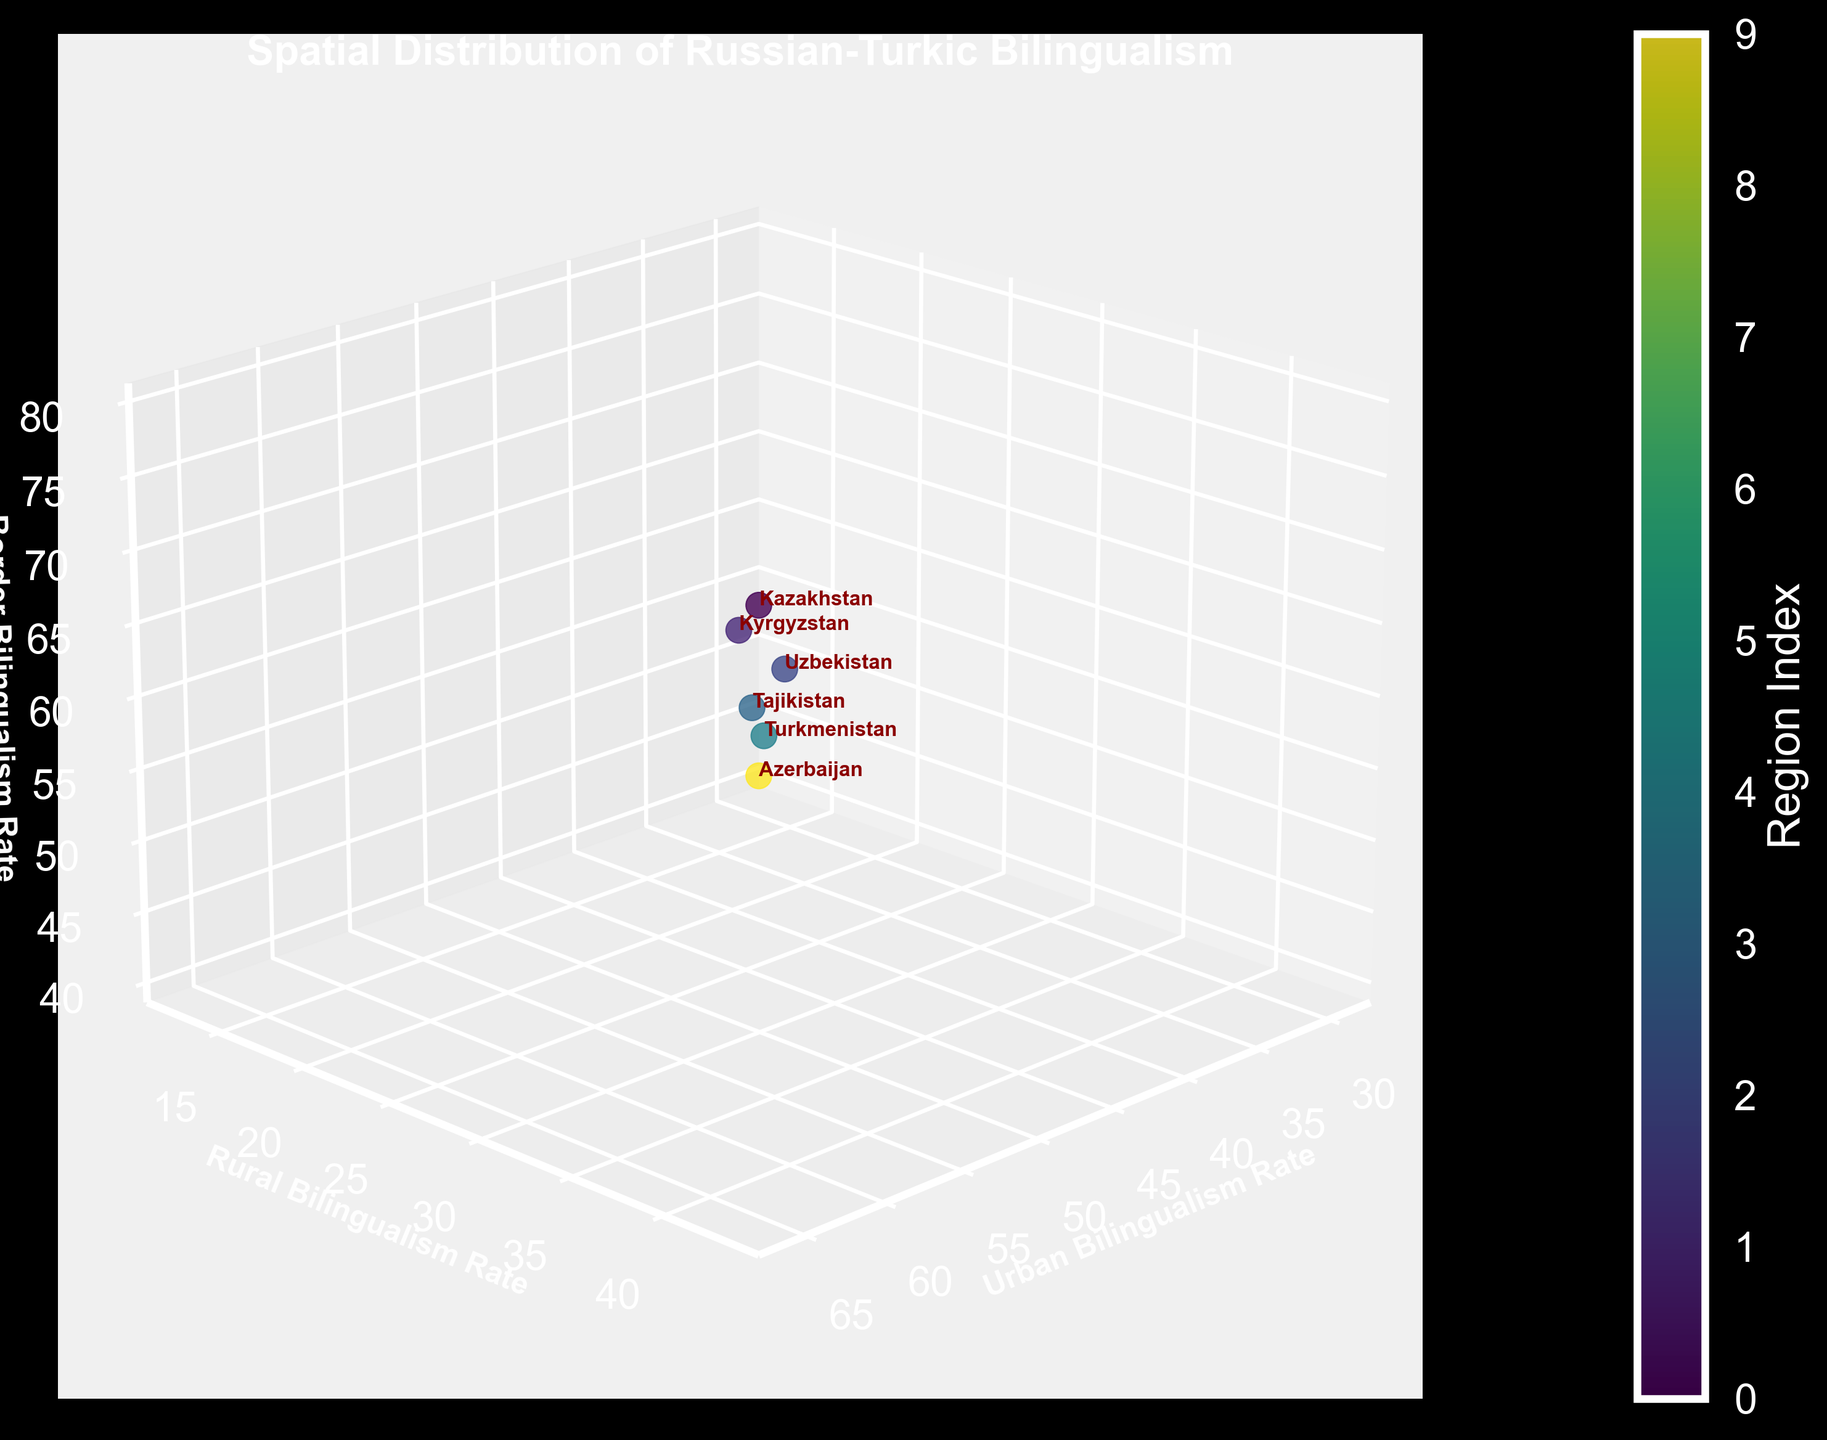What's the title of the figure? The title is typically the most prominent text in a figure, usually located at the top. In this case, the title is clearly stated at the top of the 3D plot: "Spatial Distribution of Russian-Turkic Bilingualism".
Answer: Spatial Distribution of Russian-Turkic Bilingualism Which region has the highest urban bilingualism rate? The figure displays the urban bilingualism rates along the x-axis. By looking for the region highest on this axis, we can identify Tatarstan with an urban bilingualism rate of 76.2.
Answer: Tatarstan Which regions do not have data for border bilingualism rates? By examining the z-axis values and the regions labeled, we can see that Tatarstan, Bashkortostan, Chuvashia, and Yakutia lack data points on the border bilingualism axis.
Answer: Tatarstan, Bashkortostan, Chuvashia, Yakutia What's the rural bilingualism rate of Kyrgyzstan? The y-axis represents the rural bilingualism rates. By locating Kyrgyzstan's label near this axis, we see it is positioned at a rural bilingualism rate of 36.2.
Answer: 36.2 Which region has the lowest border bilingualism rate, and what is it? The z-axis shows the border bilingualism rates. By identifying the lowest point on this axis, Azerbaijan has the lowest rate at 41.3.
Answer: Azerbaijan, 41.3 Compare the urban and rural bilingualism rates of Kazakhstan. Identify Kazakhstan's position on both the x-axis (urban) and y-axis (rural) to compare the rates of 65.3 (urban) and 42.8 (rural).
Answer: Urban: 65.3, Rural: 42.8 How does Uzbekistan compare to Kazakhstan in terms of urban bilingualism rate? Locate both Uzbekistan and Kazakhstan on the x-axis representing urban bilingualism. Uzbekistan is at 43.1, which is lower than Kazakhstan's 65.3.
Answer: Uzbekistan is lower Calculate the average urban bilingualism rate of Tatarstan, Bashkortostan, and Chuvashia. Add the urban bilingualism rates of Tatarstan (76.2), Bashkortostan (71.8), and Chuvashia (68.4) and divide by 3. (76.2 + 71.8 + 68.4) / 3 = 72.13
Answer: 72.13 Compare the border bilingualism rate between Tajikistan and Turkmenistan. Which one is higher, and by how much? Locate Tajikistan and Turkmenistan on the z-axis for border bilingualism. Tajikistan is at 52.1, and Turkmenistan is at 45.8. The difference is 52.1 - 45.8 = 6.3.
Answer: Tajikistan by 6.3 Identify the region with the most balanced bilingualism rates across urban, rural, and border categories. Calculate the ranges (difference between highest and lowest rates) for each region. Kazakhstan appears the most balanced, with urban (65.3), rural (42.8), and border (78.5), giving it a range of 35.7.
Answer: Kazakhstan 